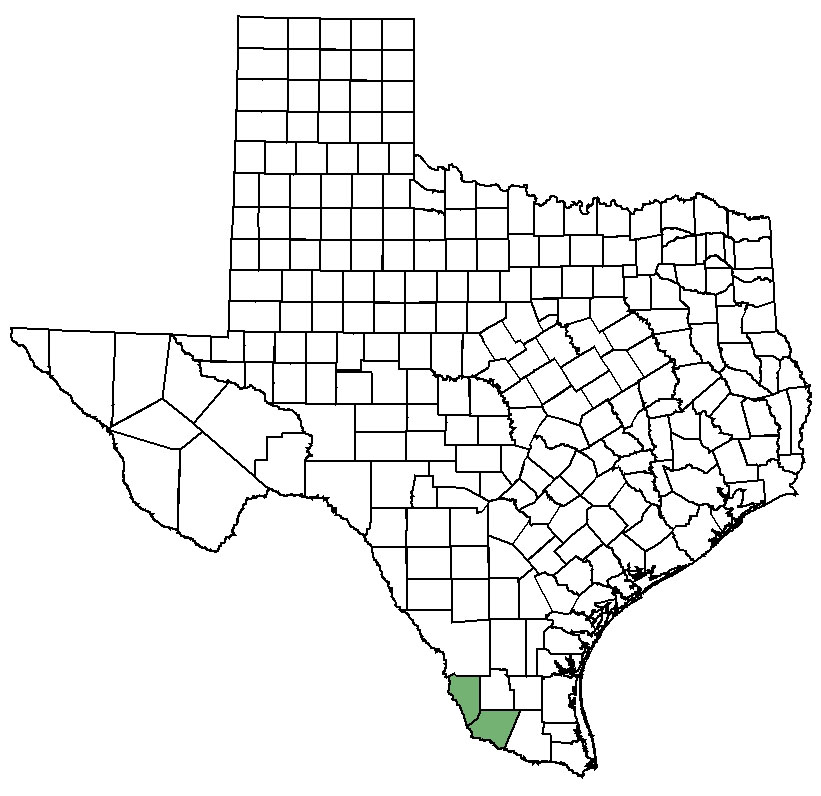Explore the potential for renewable energy in this highlighted county. The potential for renewable energy in the highlighted county is promising, offering a sustainable path forward. The county's ample sunlight makes it an excellent candidate for solar power projects. Large solar farms could harness consistent, year-round sunlight to generate electricity for local use and export. Additionally, the region's open plains are suitable for wind energy. Strategically placed wind turbines could capitalize on Texas's wind corridors to produce clean energy. Implementing these renewable energy sources could reduce reliance on fossil fuels, create jobs, and offer long-term economic benefits while promoting environmental sustainability. 